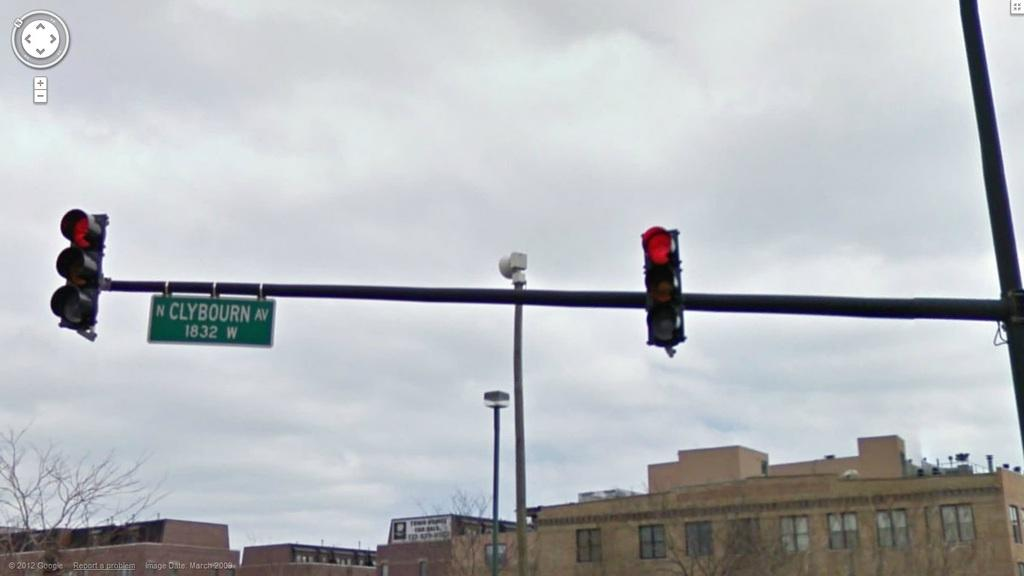<image>
Offer a succinct explanation of the picture presented. A red traffic light on North Clybourn Avenue. 